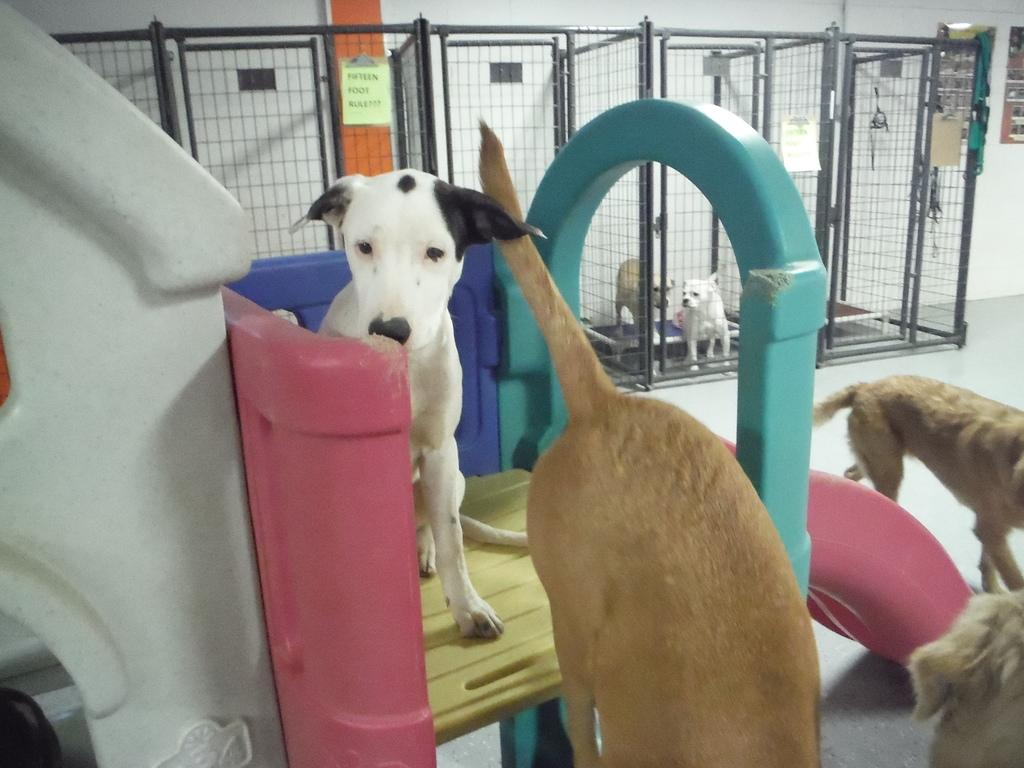What is the main object in the image? There is a slide in the image. What is on the slide? A white dog is on the slide. Are there any other dogs in the image? Yes, there are dogs near the slide. What can be seen in the background of the image? Dogs are present in cages in the background of the image, and there is a wall visible as well. What type of sticks are the dogs using to play with in the image? There are no sticks present in the image; the dogs are not shown playing with any objects. 